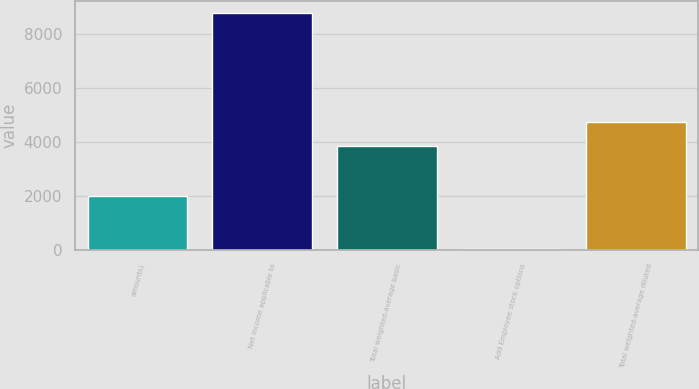<chart> <loc_0><loc_0><loc_500><loc_500><bar_chart><fcel>amounts)<fcel>Net income applicable to<fcel>Total weighted-average basic<fcel>Add Employee stock options<fcel>Total weighted-average diluted<nl><fcel>2009<fcel>8774<fcel>3862.8<fcel>16.9<fcel>4738.51<nl></chart> 